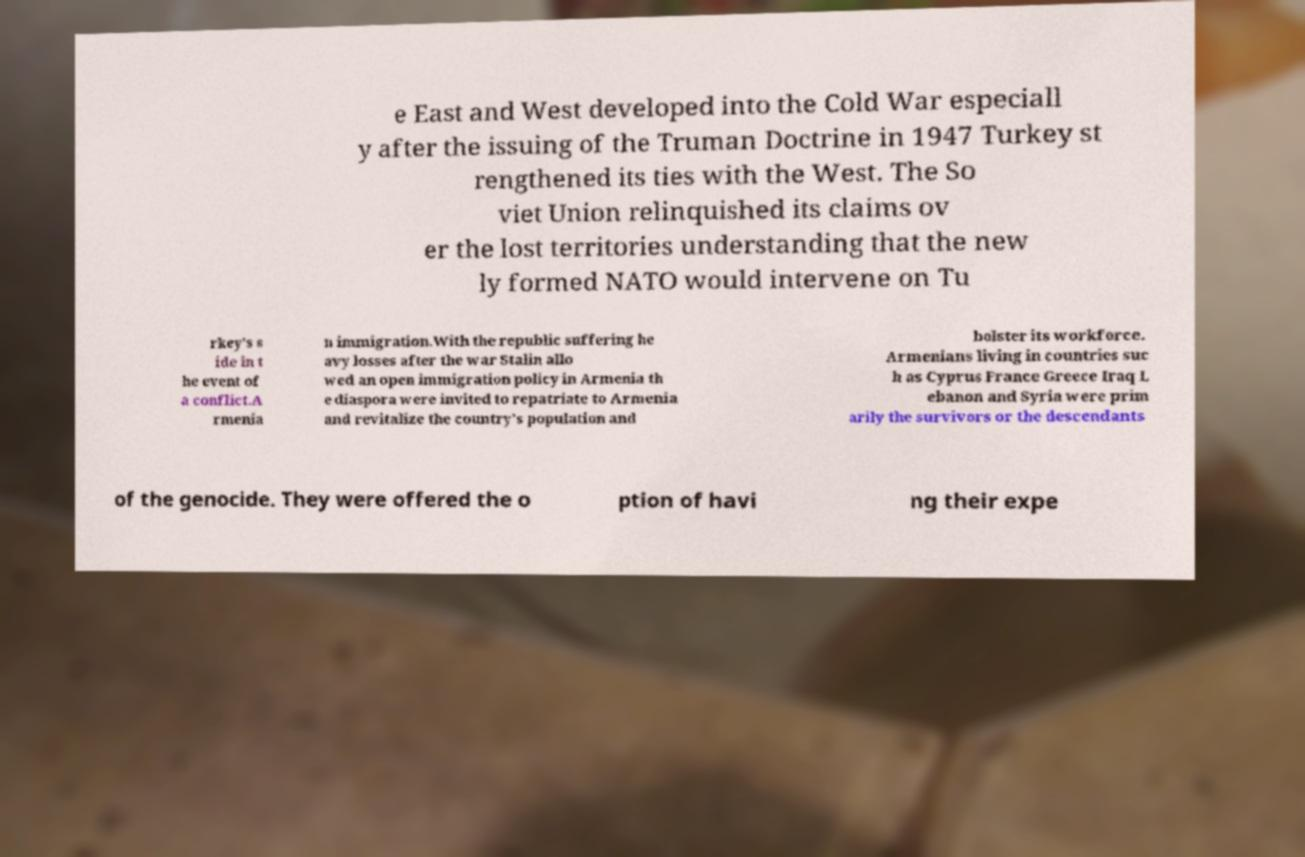Can you accurately transcribe the text from the provided image for me? e East and West developed into the Cold War especiall y after the issuing of the Truman Doctrine in 1947 Turkey st rengthened its ties with the West. The So viet Union relinquished its claims ov er the lost territories understanding that the new ly formed NATO would intervene on Tu rkey's s ide in t he event of a conflict.A rmenia n immigration.With the republic suffering he avy losses after the war Stalin allo wed an open immigration policy in Armenia th e diaspora were invited to repatriate to Armenia and revitalize the country's population and bolster its workforce. Armenians living in countries suc h as Cyprus France Greece Iraq L ebanon and Syria were prim arily the survivors or the descendants of the genocide. They were offered the o ption of havi ng their expe 